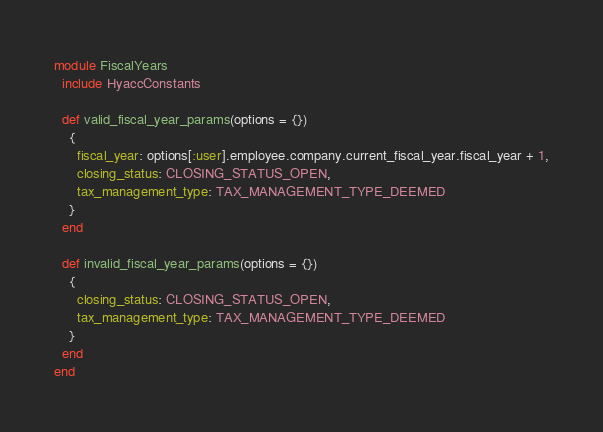<code> <loc_0><loc_0><loc_500><loc_500><_Ruby_>module FiscalYears
  include HyaccConstants

  def valid_fiscal_year_params(options = {})
    {
      fiscal_year: options[:user].employee.company.current_fiscal_year.fiscal_year + 1,
      closing_status: CLOSING_STATUS_OPEN,
      tax_management_type: TAX_MANAGEMENT_TYPE_DEEMED
    }
  end
  
  def invalid_fiscal_year_params(options = {})
    {
      closing_status: CLOSING_STATUS_OPEN,
      tax_management_type: TAX_MANAGEMENT_TYPE_DEEMED
    }
  end
end</code> 